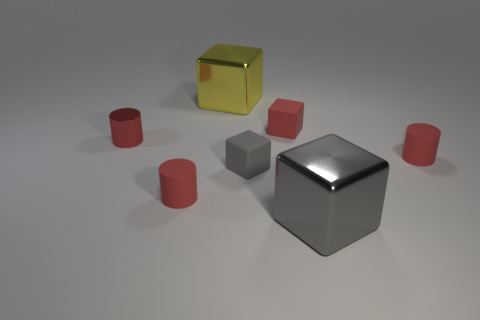Subtract all red matte blocks. How many blocks are left? 3 Add 1 red cubes. How many objects exist? 8 Subtract all yellow blocks. How many blocks are left? 3 Subtract all blue cylinders. How many gray blocks are left? 2 Subtract all cylinders. How many objects are left? 4 Subtract 1 cylinders. How many cylinders are left? 2 Subtract all purple cylinders. Subtract all gray blocks. How many cylinders are left? 3 Subtract all metallic objects. Subtract all tiny gray blocks. How many objects are left? 3 Add 3 tiny matte blocks. How many tiny matte blocks are left? 5 Add 7 large green rubber cylinders. How many large green rubber cylinders exist? 7 